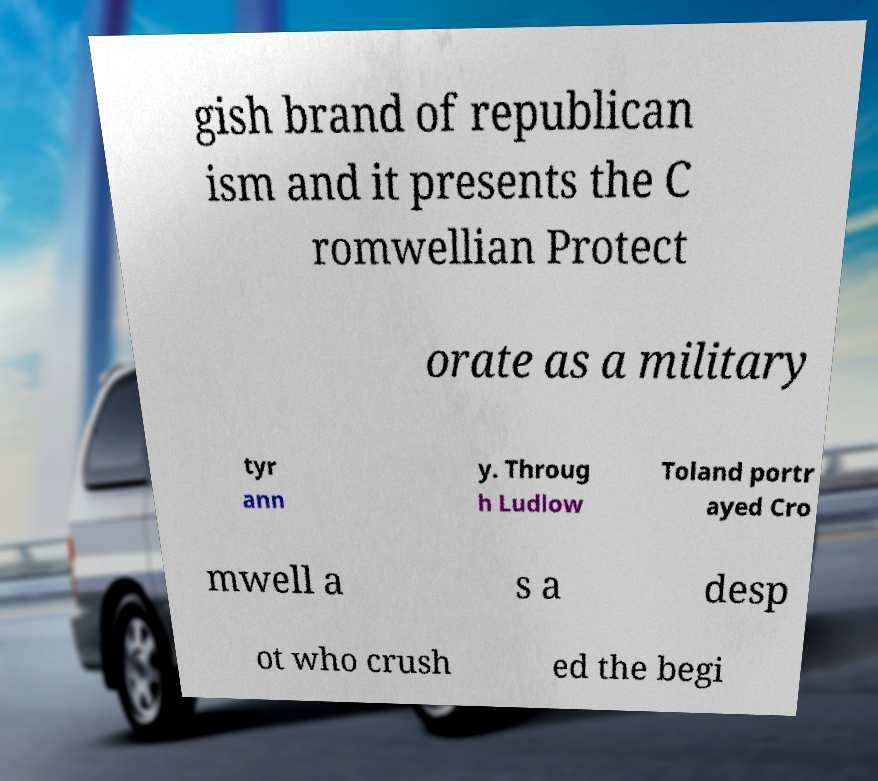Could you assist in decoding the text presented in this image and type it out clearly? gish brand of republican ism and it presents the C romwellian Protect orate as a military tyr ann y. Throug h Ludlow Toland portr ayed Cro mwell a s a desp ot who crush ed the begi 